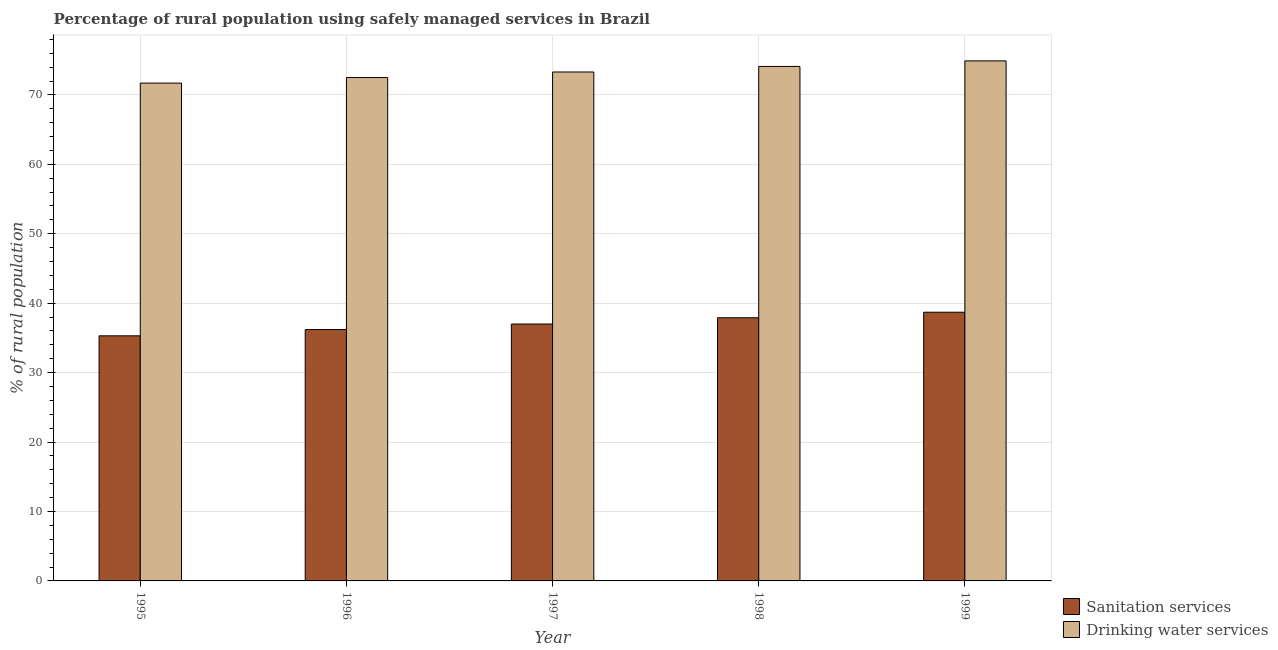How many groups of bars are there?
Keep it short and to the point. 5. Are the number of bars on each tick of the X-axis equal?
Keep it short and to the point. Yes. How many bars are there on the 4th tick from the right?
Offer a very short reply. 2. What is the percentage of rural population who used drinking water services in 1998?
Your answer should be compact. 74.1. Across all years, what is the maximum percentage of rural population who used drinking water services?
Make the answer very short. 74.9. Across all years, what is the minimum percentage of rural population who used drinking water services?
Provide a short and direct response. 71.7. In which year was the percentage of rural population who used drinking water services minimum?
Offer a very short reply. 1995. What is the total percentage of rural population who used sanitation services in the graph?
Your answer should be very brief. 185.1. What is the difference between the percentage of rural population who used drinking water services in 1996 and that in 1997?
Ensure brevity in your answer.  -0.8. What is the difference between the percentage of rural population who used drinking water services in 1996 and the percentage of rural population who used sanitation services in 1995?
Make the answer very short. 0.8. What is the average percentage of rural population who used sanitation services per year?
Give a very brief answer. 37.02. In the year 1996, what is the difference between the percentage of rural population who used drinking water services and percentage of rural population who used sanitation services?
Your answer should be very brief. 0. What is the ratio of the percentage of rural population who used drinking water services in 1997 to that in 1998?
Keep it short and to the point. 0.99. What is the difference between the highest and the second highest percentage of rural population who used drinking water services?
Offer a terse response. 0.8. What is the difference between the highest and the lowest percentage of rural population who used sanitation services?
Your answer should be compact. 3.4. In how many years, is the percentage of rural population who used sanitation services greater than the average percentage of rural population who used sanitation services taken over all years?
Your response must be concise. 2. Is the sum of the percentage of rural population who used drinking water services in 1996 and 1998 greater than the maximum percentage of rural population who used sanitation services across all years?
Your answer should be compact. Yes. What does the 2nd bar from the left in 1997 represents?
Keep it short and to the point. Drinking water services. What does the 1st bar from the right in 1997 represents?
Make the answer very short. Drinking water services. How many bars are there?
Make the answer very short. 10. Are all the bars in the graph horizontal?
Your answer should be very brief. No. Are the values on the major ticks of Y-axis written in scientific E-notation?
Your response must be concise. No. Where does the legend appear in the graph?
Provide a succinct answer. Bottom right. What is the title of the graph?
Keep it short and to the point. Percentage of rural population using safely managed services in Brazil. What is the label or title of the Y-axis?
Provide a short and direct response. % of rural population. What is the % of rural population in Sanitation services in 1995?
Your answer should be very brief. 35.3. What is the % of rural population in Drinking water services in 1995?
Provide a succinct answer. 71.7. What is the % of rural population of Sanitation services in 1996?
Provide a short and direct response. 36.2. What is the % of rural population in Drinking water services in 1996?
Your answer should be very brief. 72.5. What is the % of rural population in Sanitation services in 1997?
Offer a terse response. 37. What is the % of rural population of Drinking water services in 1997?
Provide a succinct answer. 73.3. What is the % of rural population in Sanitation services in 1998?
Provide a succinct answer. 37.9. What is the % of rural population of Drinking water services in 1998?
Your answer should be compact. 74.1. What is the % of rural population in Sanitation services in 1999?
Keep it short and to the point. 38.7. What is the % of rural population in Drinking water services in 1999?
Keep it short and to the point. 74.9. Across all years, what is the maximum % of rural population of Sanitation services?
Your answer should be very brief. 38.7. Across all years, what is the maximum % of rural population in Drinking water services?
Offer a terse response. 74.9. Across all years, what is the minimum % of rural population in Sanitation services?
Ensure brevity in your answer.  35.3. Across all years, what is the minimum % of rural population in Drinking water services?
Offer a terse response. 71.7. What is the total % of rural population in Sanitation services in the graph?
Offer a terse response. 185.1. What is the total % of rural population of Drinking water services in the graph?
Ensure brevity in your answer.  366.5. What is the difference between the % of rural population of Sanitation services in 1995 and that in 1997?
Offer a terse response. -1.7. What is the difference between the % of rural population of Sanitation services in 1995 and that in 1998?
Your answer should be compact. -2.6. What is the difference between the % of rural population of Sanitation services in 1996 and that in 1997?
Your response must be concise. -0.8. What is the difference between the % of rural population of Drinking water services in 1996 and that in 1997?
Make the answer very short. -0.8. What is the difference between the % of rural population in Sanitation services in 1996 and that in 1998?
Keep it short and to the point. -1.7. What is the difference between the % of rural population of Drinking water services in 1996 and that in 1998?
Give a very brief answer. -1.6. What is the difference between the % of rural population of Sanitation services in 1997 and that in 1998?
Ensure brevity in your answer.  -0.9. What is the difference between the % of rural population in Drinking water services in 1997 and that in 1998?
Offer a terse response. -0.8. What is the difference between the % of rural population of Sanitation services in 1997 and that in 1999?
Make the answer very short. -1.7. What is the difference between the % of rural population of Drinking water services in 1997 and that in 1999?
Your response must be concise. -1.6. What is the difference between the % of rural population in Sanitation services in 1998 and that in 1999?
Keep it short and to the point. -0.8. What is the difference between the % of rural population in Sanitation services in 1995 and the % of rural population in Drinking water services in 1996?
Your answer should be very brief. -37.2. What is the difference between the % of rural population in Sanitation services in 1995 and the % of rural population in Drinking water services in 1997?
Make the answer very short. -38. What is the difference between the % of rural population in Sanitation services in 1995 and the % of rural population in Drinking water services in 1998?
Provide a short and direct response. -38.8. What is the difference between the % of rural population in Sanitation services in 1995 and the % of rural population in Drinking water services in 1999?
Keep it short and to the point. -39.6. What is the difference between the % of rural population of Sanitation services in 1996 and the % of rural population of Drinking water services in 1997?
Make the answer very short. -37.1. What is the difference between the % of rural population of Sanitation services in 1996 and the % of rural population of Drinking water services in 1998?
Keep it short and to the point. -37.9. What is the difference between the % of rural population of Sanitation services in 1996 and the % of rural population of Drinking water services in 1999?
Make the answer very short. -38.7. What is the difference between the % of rural population in Sanitation services in 1997 and the % of rural population in Drinking water services in 1998?
Provide a short and direct response. -37.1. What is the difference between the % of rural population in Sanitation services in 1997 and the % of rural population in Drinking water services in 1999?
Keep it short and to the point. -37.9. What is the difference between the % of rural population of Sanitation services in 1998 and the % of rural population of Drinking water services in 1999?
Keep it short and to the point. -37. What is the average % of rural population in Sanitation services per year?
Keep it short and to the point. 37.02. What is the average % of rural population in Drinking water services per year?
Offer a terse response. 73.3. In the year 1995, what is the difference between the % of rural population in Sanitation services and % of rural population in Drinking water services?
Your answer should be compact. -36.4. In the year 1996, what is the difference between the % of rural population in Sanitation services and % of rural population in Drinking water services?
Provide a succinct answer. -36.3. In the year 1997, what is the difference between the % of rural population in Sanitation services and % of rural population in Drinking water services?
Make the answer very short. -36.3. In the year 1998, what is the difference between the % of rural population of Sanitation services and % of rural population of Drinking water services?
Keep it short and to the point. -36.2. In the year 1999, what is the difference between the % of rural population of Sanitation services and % of rural population of Drinking water services?
Provide a succinct answer. -36.2. What is the ratio of the % of rural population of Sanitation services in 1995 to that in 1996?
Provide a succinct answer. 0.98. What is the ratio of the % of rural population in Sanitation services in 1995 to that in 1997?
Keep it short and to the point. 0.95. What is the ratio of the % of rural population in Drinking water services in 1995 to that in 1997?
Keep it short and to the point. 0.98. What is the ratio of the % of rural population in Sanitation services in 1995 to that in 1998?
Offer a very short reply. 0.93. What is the ratio of the % of rural population in Drinking water services in 1995 to that in 1998?
Make the answer very short. 0.97. What is the ratio of the % of rural population in Sanitation services in 1995 to that in 1999?
Give a very brief answer. 0.91. What is the ratio of the % of rural population of Drinking water services in 1995 to that in 1999?
Provide a succinct answer. 0.96. What is the ratio of the % of rural population in Sanitation services in 1996 to that in 1997?
Offer a very short reply. 0.98. What is the ratio of the % of rural population of Sanitation services in 1996 to that in 1998?
Offer a terse response. 0.96. What is the ratio of the % of rural population of Drinking water services in 1996 to that in 1998?
Ensure brevity in your answer.  0.98. What is the ratio of the % of rural population in Sanitation services in 1996 to that in 1999?
Your answer should be very brief. 0.94. What is the ratio of the % of rural population in Sanitation services in 1997 to that in 1998?
Your answer should be compact. 0.98. What is the ratio of the % of rural population of Drinking water services in 1997 to that in 1998?
Offer a very short reply. 0.99. What is the ratio of the % of rural population of Sanitation services in 1997 to that in 1999?
Provide a succinct answer. 0.96. What is the ratio of the % of rural population in Drinking water services in 1997 to that in 1999?
Keep it short and to the point. 0.98. What is the ratio of the % of rural population of Sanitation services in 1998 to that in 1999?
Give a very brief answer. 0.98. What is the ratio of the % of rural population in Drinking water services in 1998 to that in 1999?
Your answer should be compact. 0.99. What is the difference between the highest and the second highest % of rural population of Sanitation services?
Provide a short and direct response. 0.8. What is the difference between the highest and the second highest % of rural population of Drinking water services?
Offer a very short reply. 0.8. What is the difference between the highest and the lowest % of rural population of Drinking water services?
Give a very brief answer. 3.2. 